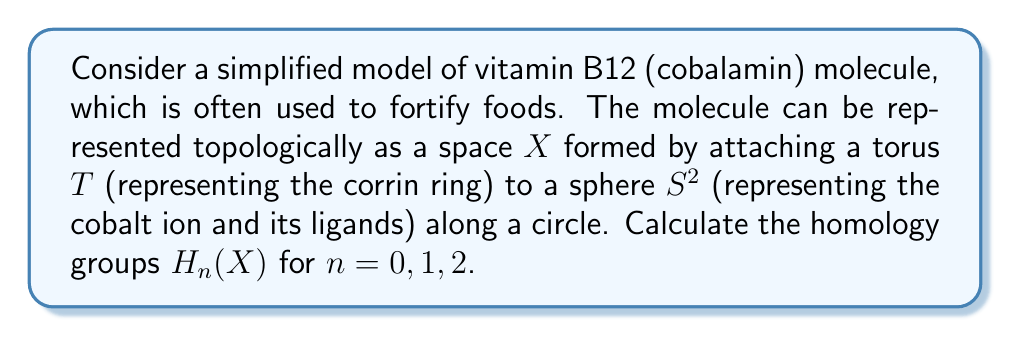Give your solution to this math problem. To solve this problem, we'll use the Mayer-Vietoris sequence and the known homology groups of the torus and sphere.

1) First, recall the homology groups of the torus $T$ and sphere $S^2$:

   For $T$: $H_0(T) \cong \mathbb{Z}$, $H_1(T) \cong \mathbb{Z} \oplus \mathbb{Z}$, $H_2(T) \cong \mathbb{Z}$
   For $S^2$: $H_0(S^2) \cong \mathbb{Z}$, $H_1(S^2) \cong 0$, $H_2(S^2) \cong \mathbb{Z}$

2) Let $A$ be a small neighborhood of the attaching circle on the torus, and $B$ be the complement of a slightly smaller neighborhood. Then $A \cap B$ is homotopy equivalent to $S^1$, $A$ is homotopy equivalent to $S^1$, and $X = A \cup B$.

3) The Mayer-Vietoris sequence gives us:

   $$... \to H_n(A \cap B) \to H_n(A) \oplus H_n(B) \to H_n(X) \to H_{n-1}(A \cap B) \to ...$$

4) For $n = 0$:
   
   $$0 \to H_0(S^1) \to H_0(S^1) \oplus H_0(B) \to H_0(X) \to 0$$
   
   This gives $H_0(X) \cong \mathbb{Z}$, as expected for a connected space.

5) For $n = 1$:
   
   $$0 \to H_1(S^1) \to H_1(S^1) \oplus H_1(B) \to H_1(X) \to H_0(S^1) \to H_0(S^1) \oplus H_0(B) \to H_0(X) \to 0$$
   
   Simplifying: $0 \to \mathbb{Z} \to \mathbb{Z} \oplus \mathbb{Z} \to H_1(X) \to \mathbb{Z} \to \mathbb{Z} \oplus \mathbb{Z} \to \mathbb{Z} \to 0$
   
   This gives $H_1(X) \cong \mathbb{Z}$.

6) For $n = 2$:
   
   $$0 \to H_2(S^1) \to H_2(S^1) \oplus H_2(B) \to H_2(X) \to H_1(S^1) \to H_1(S^1) \oplus H_1(B) \to H_1(X) \to 0$$
   
   Simplifying: $0 \to 0 \to \mathbb{Z} \to H_2(X) \to \mathbb{Z} \to \mathbb{Z} \oplus \mathbb{Z} \to \mathbb{Z} \to 0$
   
   This gives $H_2(X) \cong \mathbb{Z}$.

7) For $n > 2$, all groups in the sequence are 0, so $H_n(X) \cong 0$ for $n > 2$.
Answer: The homology groups of $X$ are:

$H_0(X) \cong \mathbb{Z}$
$H_1(X) \cong \mathbb{Z}$
$H_2(X) \cong \mathbb{Z}$
$H_n(X) \cong 0$ for $n > 2$ 